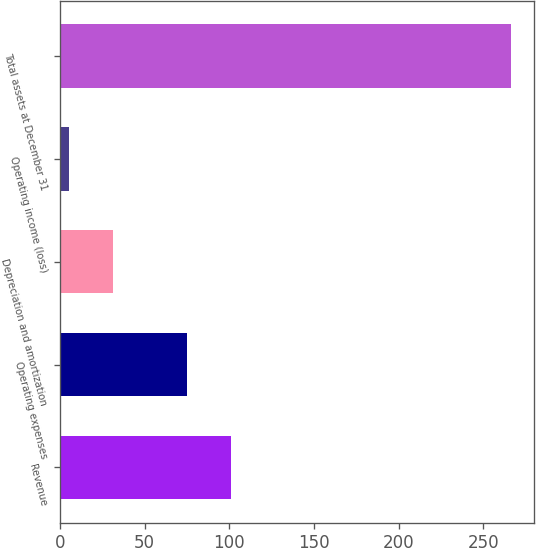<chart> <loc_0><loc_0><loc_500><loc_500><bar_chart><fcel>Revenue<fcel>Operating expenses<fcel>Depreciation and amortization<fcel>Operating income (loss)<fcel>Total assets at December 31<nl><fcel>101.03<fcel>74.9<fcel>31.43<fcel>5.3<fcel>266.6<nl></chart> 